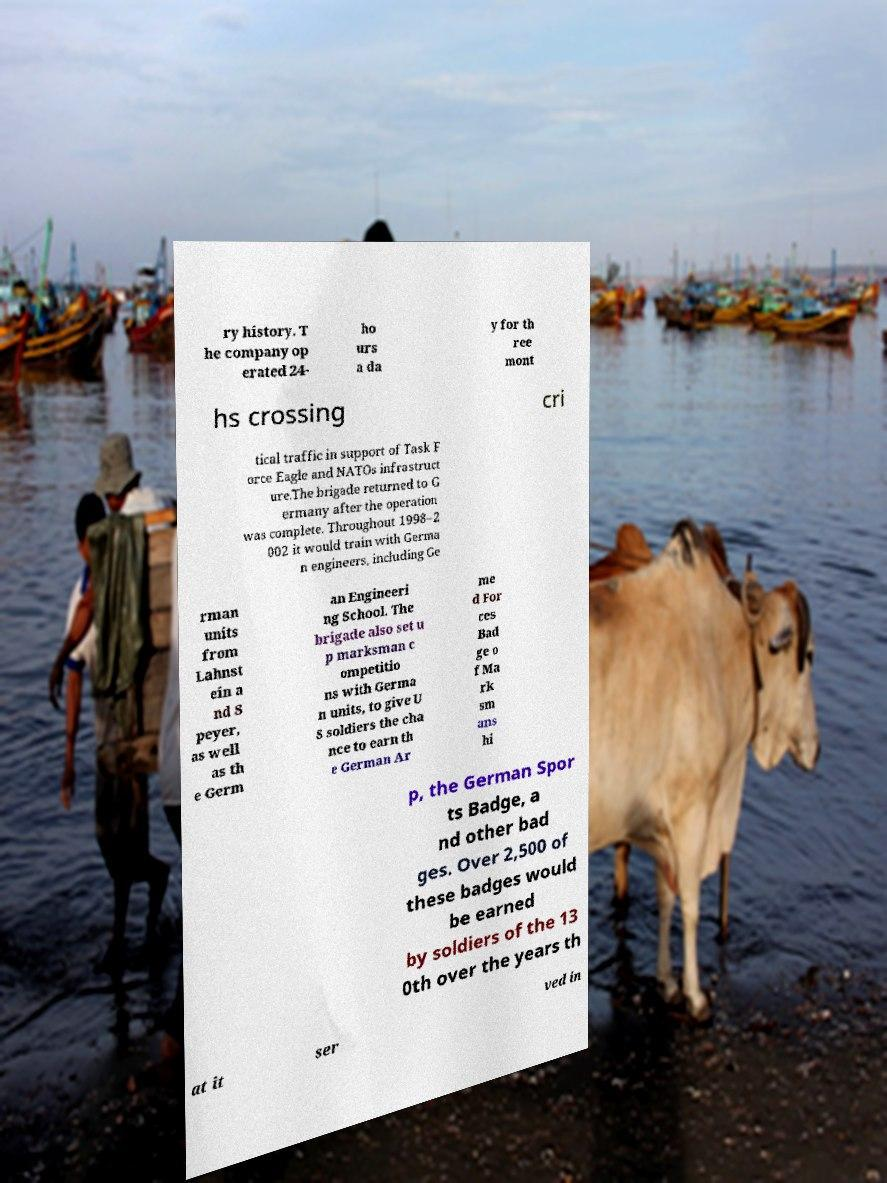There's text embedded in this image that I need extracted. Can you transcribe it verbatim? ry history. T he company op erated 24- ho urs a da y for th ree mont hs crossing cri tical traffic in support of Task F orce Eagle and NATOs infrastruct ure.The brigade returned to G ermany after the operation was complete. Throughout 1998–2 002 it would train with Germa n engineers, including Ge rman units from Lahnst ein a nd S peyer, as well as th e Germ an Engineeri ng School. The brigade also set u p marksman c ompetitio ns with Germa n units, to give U S soldiers the cha nce to earn th e German Ar me d For ces Bad ge o f Ma rk sm ans hi p, the German Spor ts Badge, a nd other bad ges. Over 2,500 of these badges would be earned by soldiers of the 13 0th over the years th at it ser ved in 